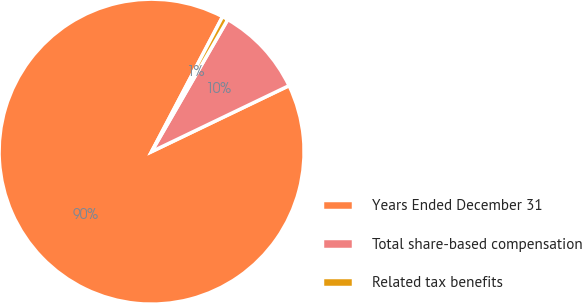<chart> <loc_0><loc_0><loc_500><loc_500><pie_chart><fcel>Years Ended December 31<fcel>Total share-based compensation<fcel>Related tax benefits<nl><fcel>89.83%<fcel>9.55%<fcel>0.62%<nl></chart> 